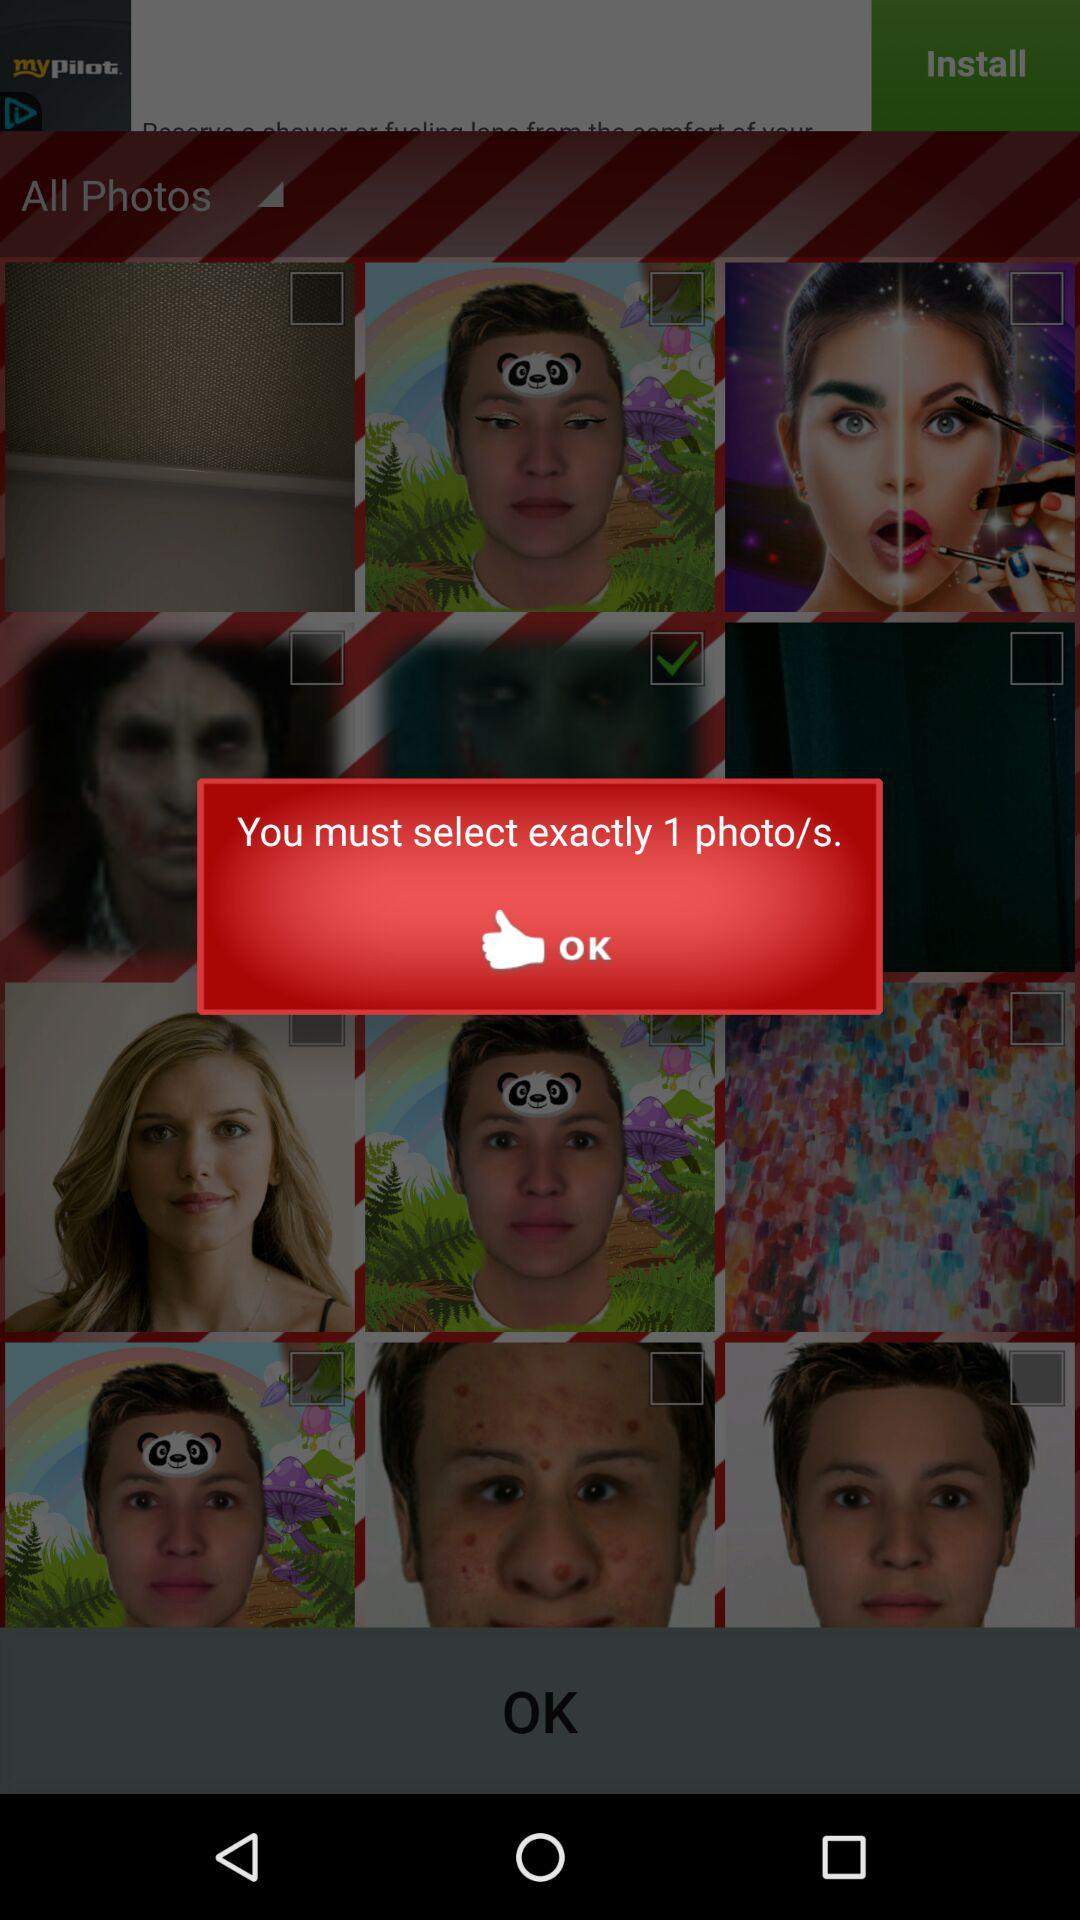How many more photos do I need to select?
Answer the question using a single word or phrase. 0 